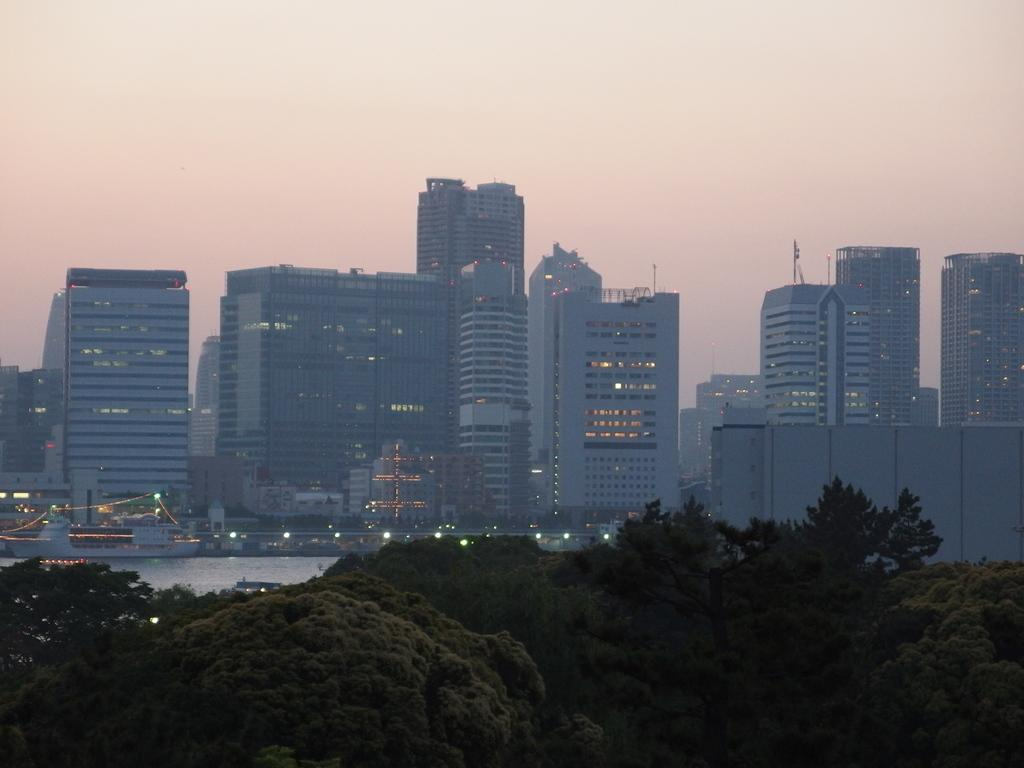What type of structures are present in the image? There are buildings in the image. Where are the buildings located in relation to the water? The buildings are near water in the image. What can be seen in the background of the image? There are trees, lights, and the sky visible in the background of the image. How many bags of sugar are visible in the image? There are no bags of sugar present in the image. Are there any chickens visible in the image? There are no chickens present in the image. 